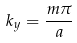Convert formula to latex. <formula><loc_0><loc_0><loc_500><loc_500>k _ { y } = \frac { m \pi } { a }</formula> 